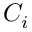<formula> <loc_0><loc_0><loc_500><loc_500>C _ { i }</formula> 